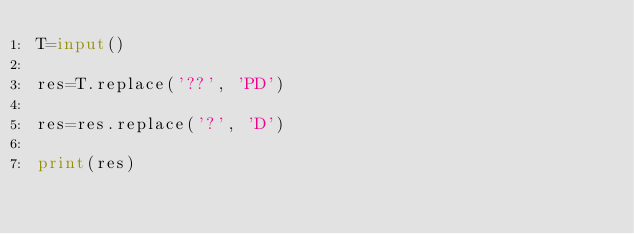Convert code to text. <code><loc_0><loc_0><loc_500><loc_500><_Python_>T=input()

res=T.replace('??', 'PD')

res=res.replace('?', 'D')

print(res)</code> 